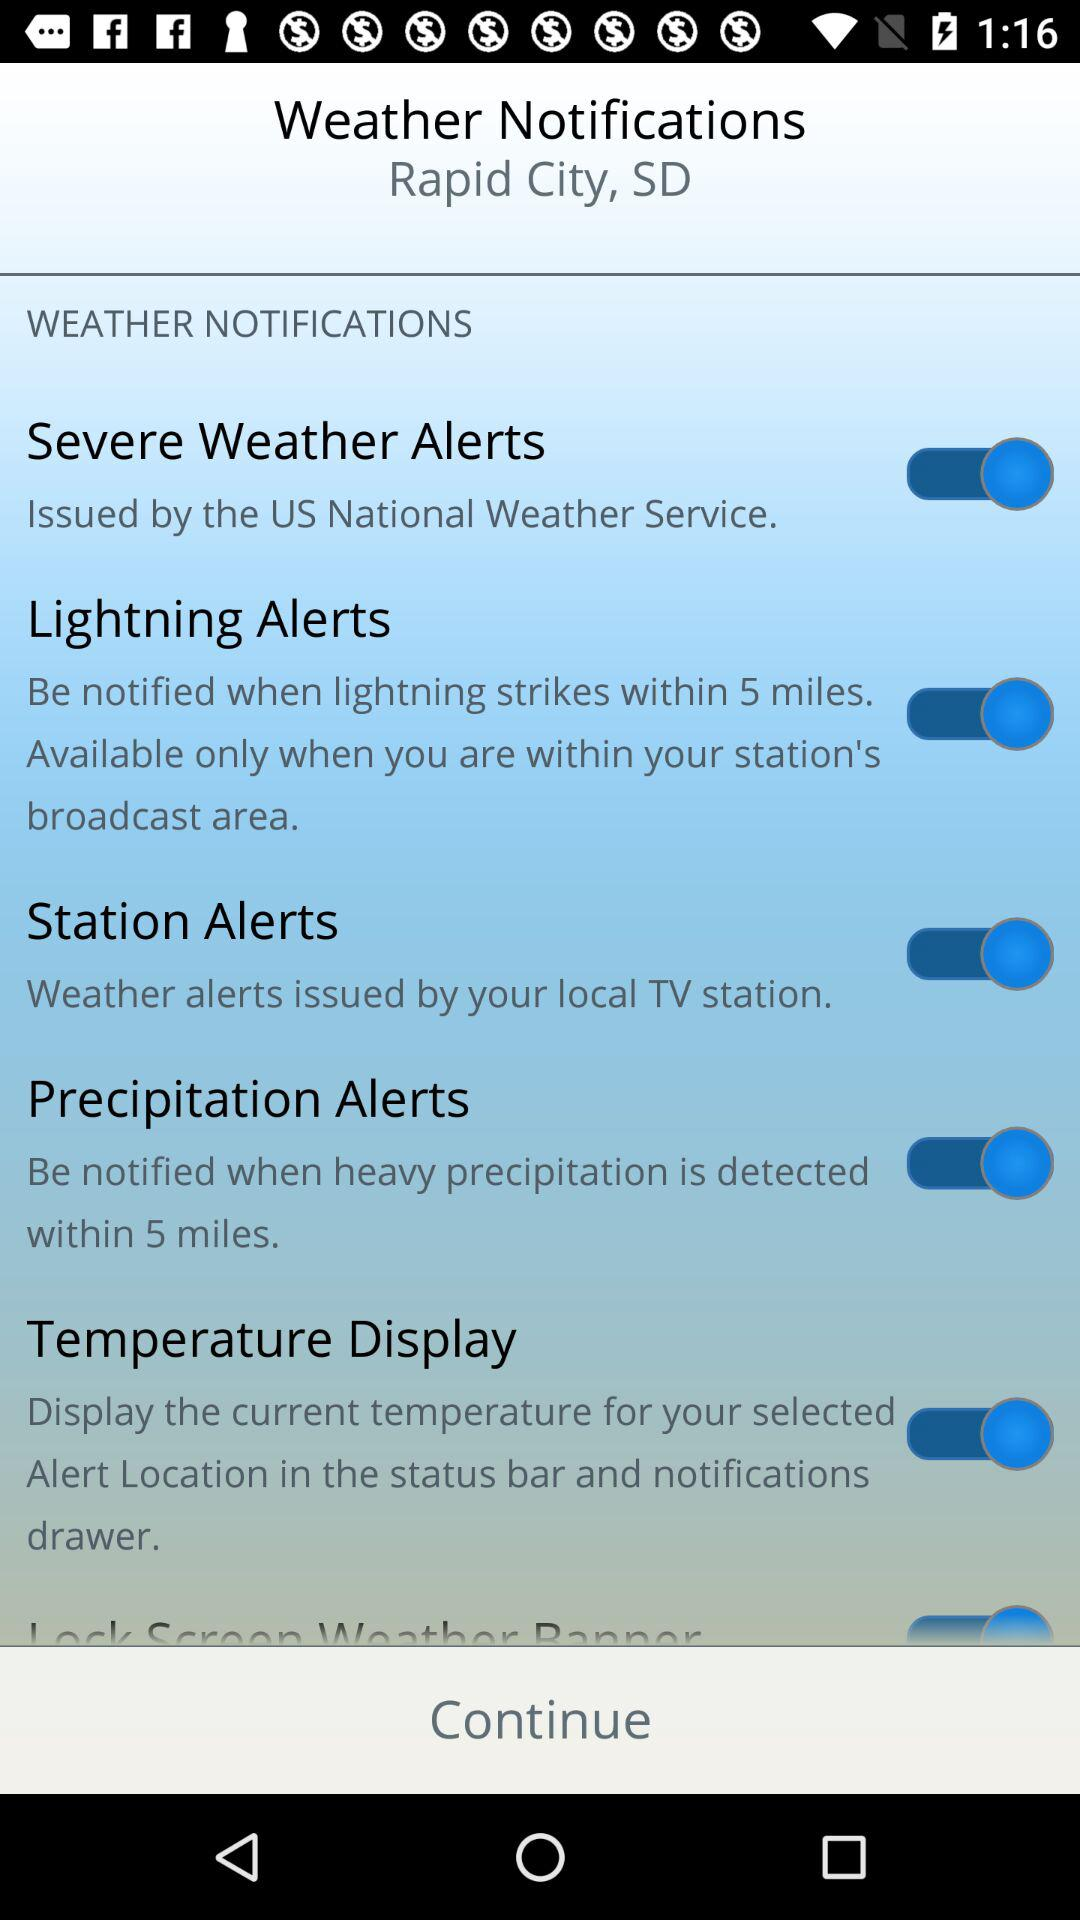Who issues severe weather alerts? Severe weather alerts are issued by the "US National Weather Service". 